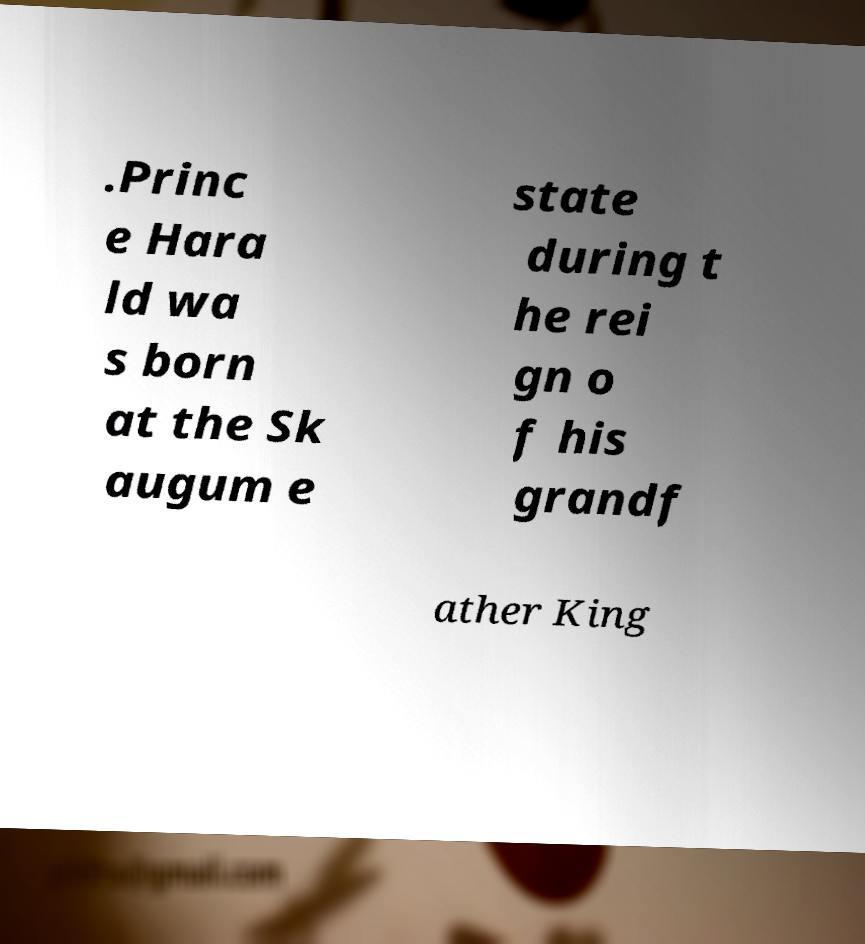Please read and relay the text visible in this image. What does it say? .Princ e Hara ld wa s born at the Sk augum e state during t he rei gn o f his grandf ather King 